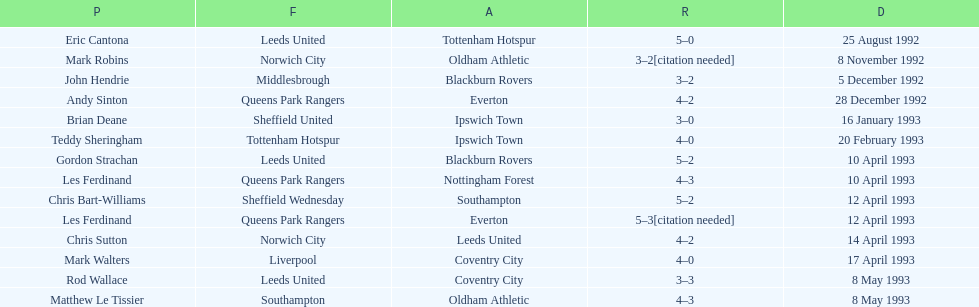What was the result of the match between queens park rangers and everton? 4-2. 